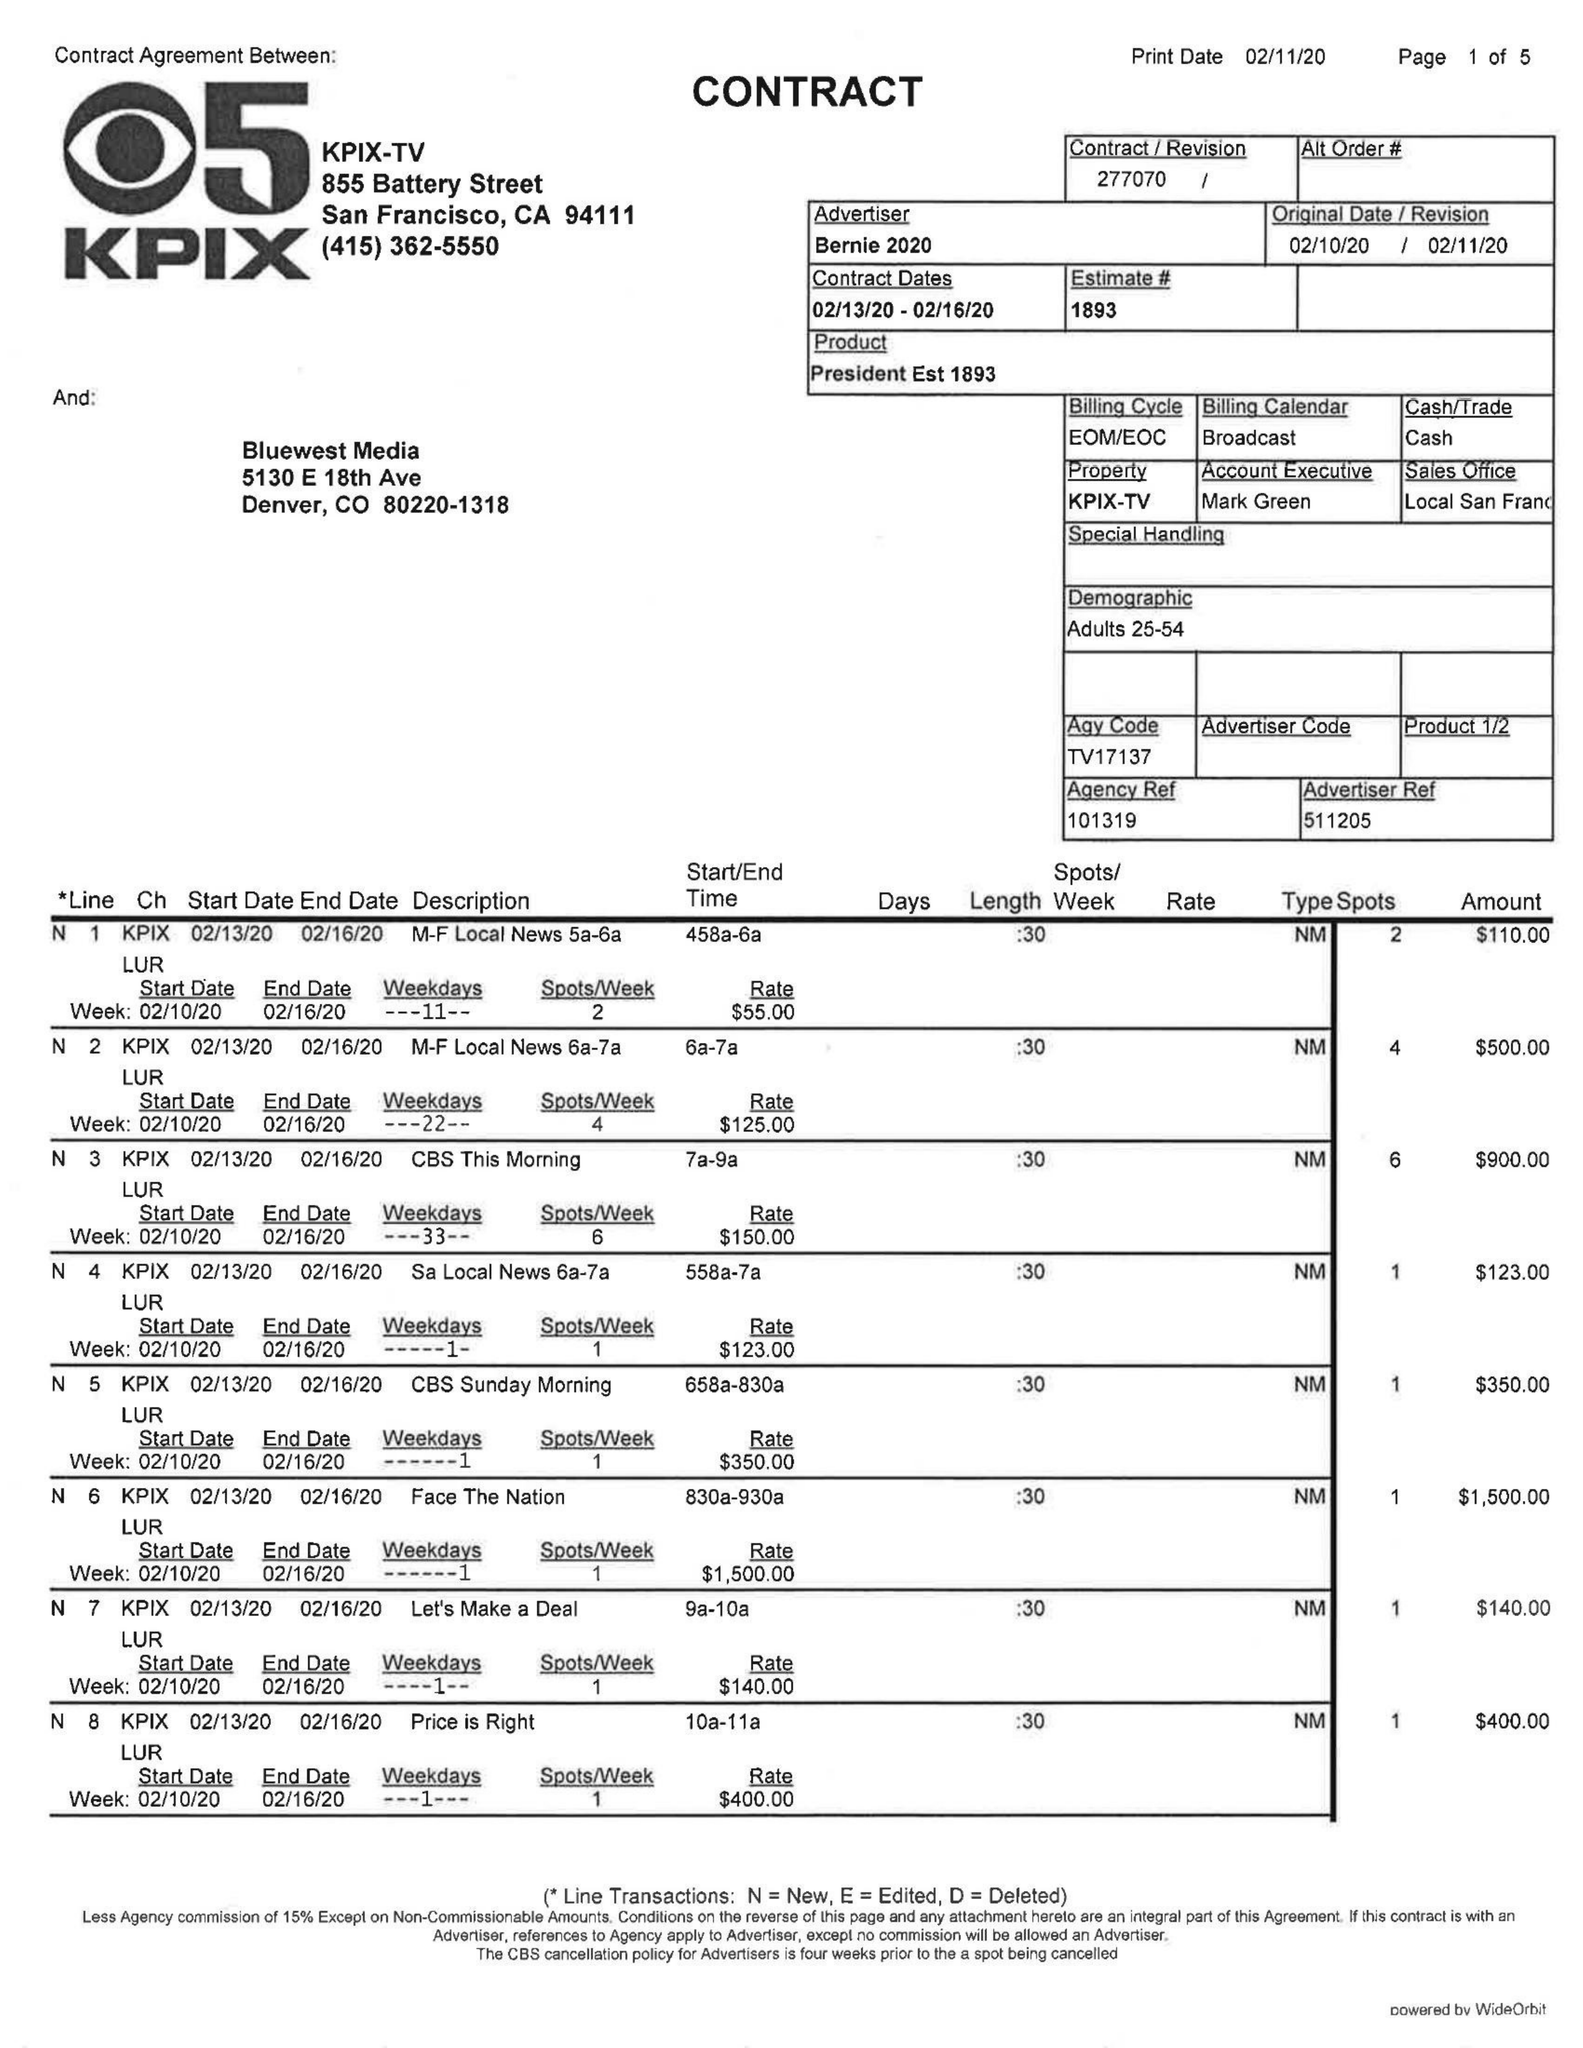What is the value for the flight_to?
Answer the question using a single word or phrase. 02/16/20 